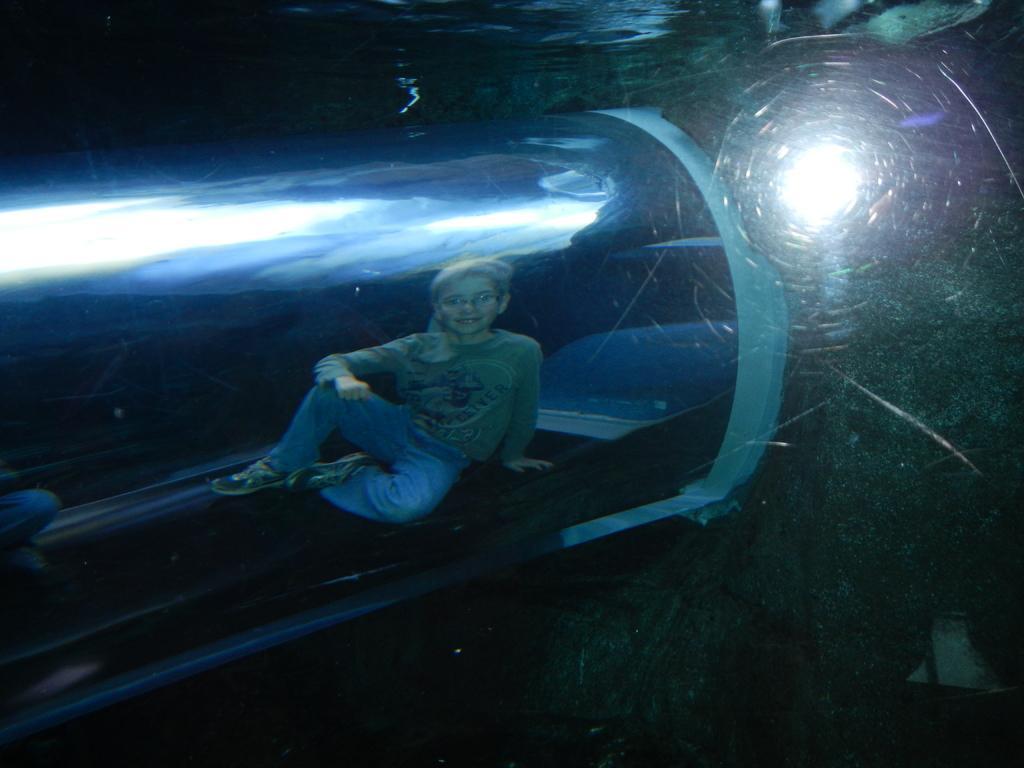Describe this image in one or two sentences. In this image there is a person sitting inside the transparent cubicle. Behind the person there is a light. 